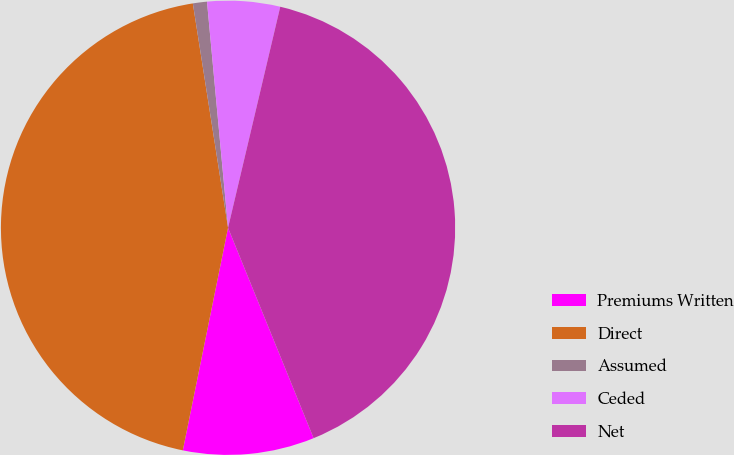<chart> <loc_0><loc_0><loc_500><loc_500><pie_chart><fcel>Premiums Written<fcel>Direct<fcel>Assumed<fcel>Ceded<fcel>Net<nl><fcel>9.34%<fcel>44.33%<fcel>1.0%<fcel>5.17%<fcel>40.16%<nl></chart> 